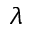Convert formula to latex. <formula><loc_0><loc_0><loc_500><loc_500>\lambda</formula> 